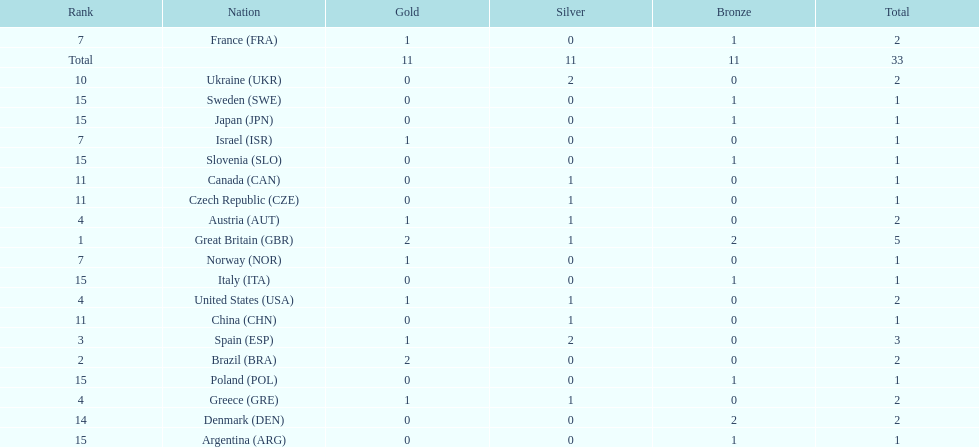What country had the most medals? Great Britain. 